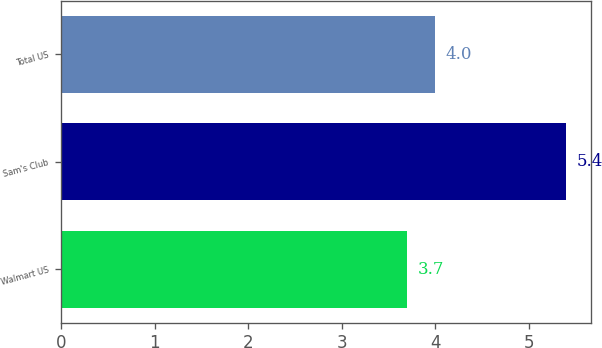<chart> <loc_0><loc_0><loc_500><loc_500><bar_chart><fcel>Walmart US<fcel>Sam's Club<fcel>Total US<nl><fcel>3.7<fcel>5.4<fcel>4<nl></chart> 